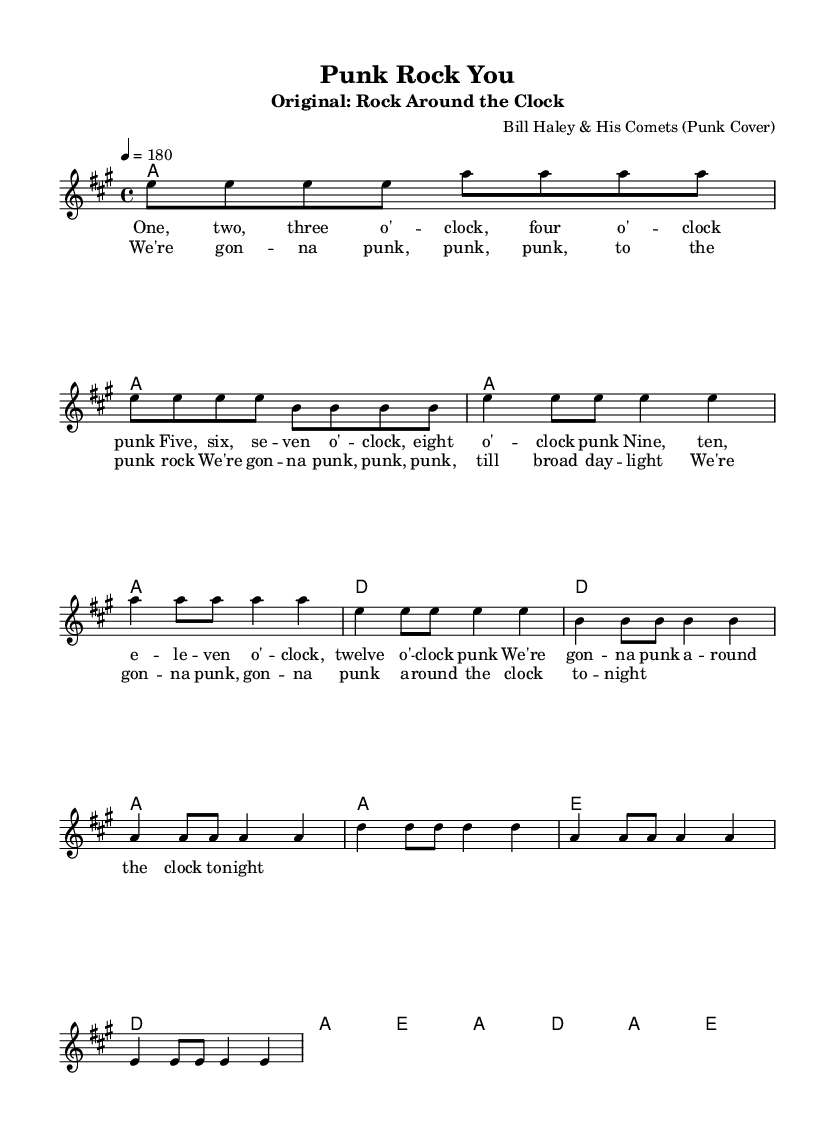What is the key signature of this music? The key signature indicates the key of A major, which has three sharps: F#, C#, and G#.
Answer: A major What is the time signature of this music? The time signature is represented at the beginning of the sheet music, showing there are four beats in each measure, which is denoted as 4/4.
Answer: 4/4 What is the tempo marking of this music? The tempo marking indicates that the music should be played at a speed of 180 beats per minute, expressed as "4 = 180".
Answer: 180 How many measures are there in the verse section? Counting the measures in the verse provided in the melody, there are 8 measures in total for the verse section.
Answer: 8 Which chords are used in the chorus? The chords used in the chorus are A major, D major, and E major, identified through the chord symbols listed above the melody.
Answer: A, D, E What is the main theme of the lyrics in the chorus? The chorus expresses the idea of partying or "punking" around the clock, which is an energetic and rebellious theme characteristic of punk music.
Answer: Punk rock How do the lyric lines correspond to the melody? The lyrics are aligned with the notes of the melody in a way that each syllable corresponds to a rhythmic value, showcasing the relationship between the lyrics and the music structure, especially in the chorus.
Answer: Corresponding alignment 